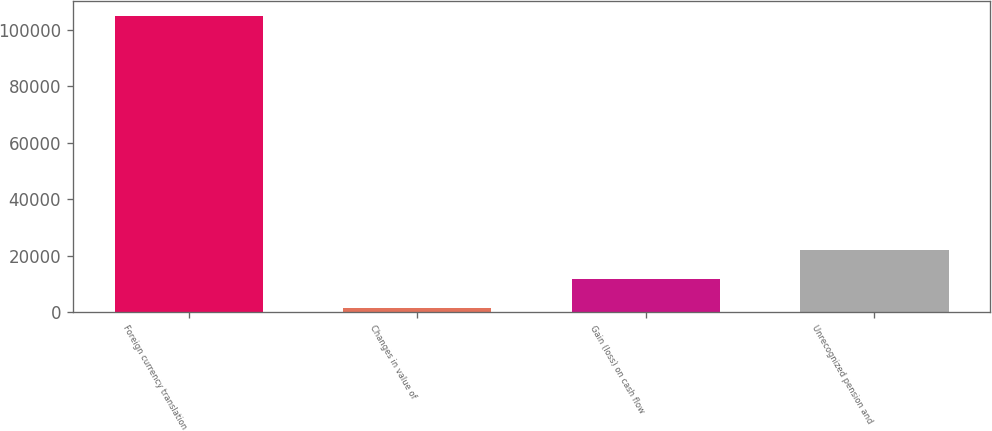Convert chart. <chart><loc_0><loc_0><loc_500><loc_500><bar_chart><fcel>Foreign currency translation<fcel>Changes in value of<fcel>Gain (loss) on cash flow<fcel>Unrecognized pension and<nl><fcel>104872<fcel>1489<fcel>11827.3<fcel>22165.6<nl></chart> 